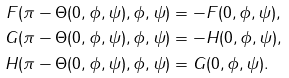Convert formula to latex. <formula><loc_0><loc_0><loc_500><loc_500>F ( \pi - \Theta ( 0 , \phi , \psi ) , \phi , \psi ) & = - F ( 0 , \phi , \psi ) , \\ G ( \pi - \Theta ( 0 , \phi , \psi ) , \phi , \psi ) & = - H ( 0 , \phi , \psi ) , \\ H ( \pi - \Theta ( 0 , \phi , \psi ) , \phi , \psi ) & = G ( 0 , \phi , \psi ) .</formula> 